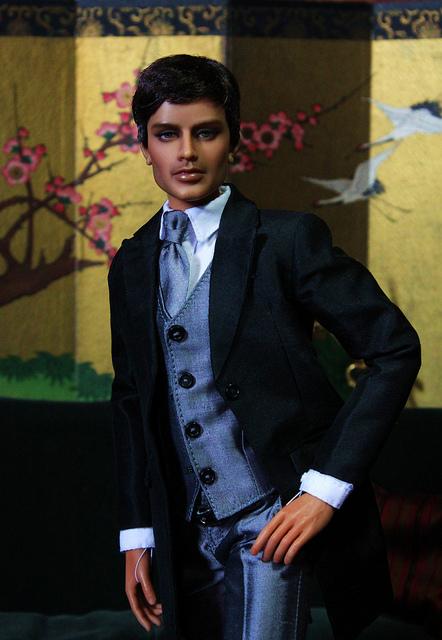Does the painting in the background look asian inspired?
Write a very short answer. Yes. How many buttons are on the shirt?
Concise answer only. 4. What color is the tie?
Keep it brief. Gray. What indicates that the man in the suit is actually a mannequin?
Be succinct. His face. 